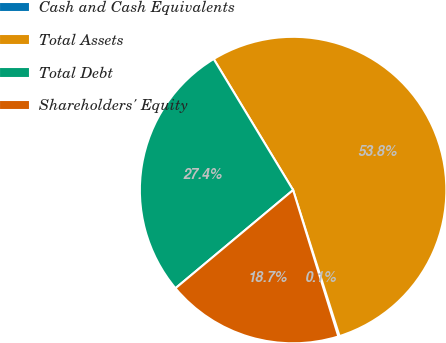Convert chart to OTSL. <chart><loc_0><loc_0><loc_500><loc_500><pie_chart><fcel>Cash and Cash Equivalents<fcel>Total Assets<fcel>Total Debt<fcel>Shareholders' Equity<nl><fcel>0.13%<fcel>53.77%<fcel>27.4%<fcel>18.7%<nl></chart> 